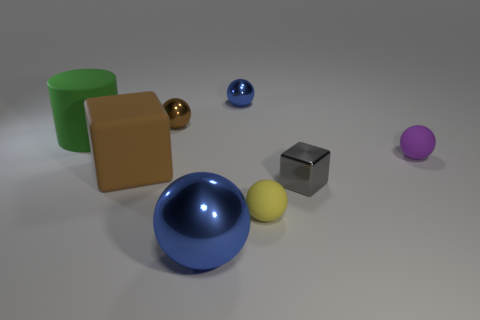Is there any other thing that is the same color as the large matte block?
Ensure brevity in your answer.  Yes. Does the rubber block have the same color as the metal sphere that is in front of the large cylinder?
Your answer should be very brief. No. Are there fewer big blue spheres that are on the right side of the gray metal object than blue objects?
Your response must be concise. Yes. What is the blue object behind the small gray shiny block made of?
Offer a terse response. Metal. What number of other things are there of the same size as the gray cube?
Give a very brief answer. 4. There is a brown shiny object; does it have the same size as the metal object in front of the small yellow rubber ball?
Offer a terse response. No. There is a tiny thing that is on the left side of the blue ball on the right side of the metallic object that is in front of the yellow matte ball; what shape is it?
Provide a short and direct response. Sphere. Is the number of green cylinders less than the number of small yellow shiny blocks?
Ensure brevity in your answer.  No. There is a purple ball; are there any small purple matte spheres behind it?
Give a very brief answer. No. What shape is the thing that is behind the purple thing and on the left side of the tiny brown metal sphere?
Your response must be concise. Cylinder. 